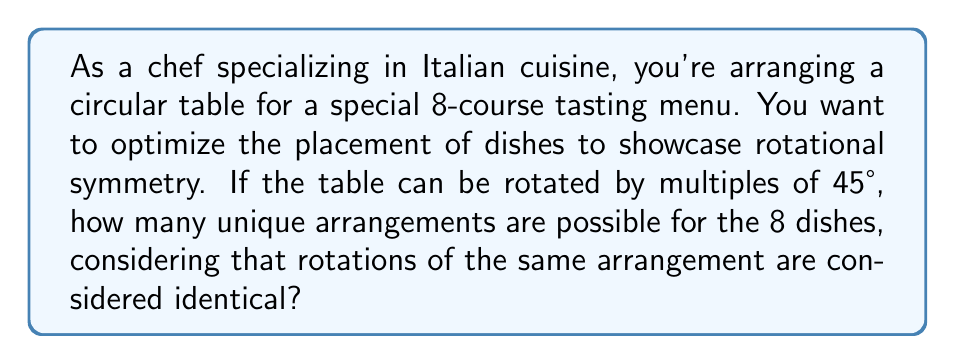Provide a solution to this math problem. To solve this problem, we can use concepts from Lie theory, specifically the cyclic group $C_8$ which represents the rotational symmetry of the table.

1) First, we need to understand that the table has 8-fold rotational symmetry, represented by the cyclic group $C_8$.

2) The total number of ways to arrange 8 dishes without considering symmetry is 8! = 40,320.

3) However, we consider rotations of the same arrangement as identical. This means we need to use Burnside's lemma from group theory.

4) Burnside's lemma states that the number of orbits (unique arrangements) is equal to the average number of elements fixed by each group element:

   $$ |X/G| = \frac{1}{|G|} \sum_{g \in G} |X^g| $$

   Where $X$ is the set of all arrangements, $G$ is the group of symmetries, and $X^g$ is the set of arrangements fixed by the symmetry $g$.

5) In our case, $|G| = 8$ (the order of $C_8$).

6) Now, we need to count the fixed points for each rotation:
   - Identity rotation (0°): fixes all 8! arrangements
   - 45°, 90°, 135°, 180°, 225°, 270°, 315° rotations: fix no arrangements

7) Applying Burnside's lemma:

   $$ |X/G| = \frac{1}{8} (8! + 0 + 0 + 0 + 0 + 0 + 0 + 0) = \frac{8!}{8} = 7! = 5,040 $$

Therefore, there are 5,040 unique arrangements of the 8 dishes on the circular table.
Answer: 5,040 unique arrangements 